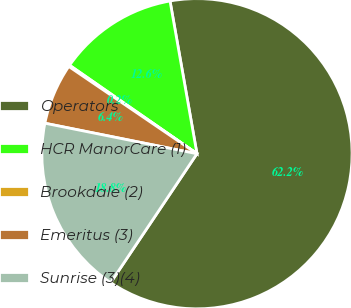Convert chart. <chart><loc_0><loc_0><loc_500><loc_500><pie_chart><fcel>Operators<fcel>HCR ManorCare (1)<fcel>Brookdale (2)<fcel>Emeritus (3)<fcel>Sunrise (3)(4)<nl><fcel>62.17%<fcel>12.56%<fcel>0.15%<fcel>6.36%<fcel>18.76%<nl></chart> 